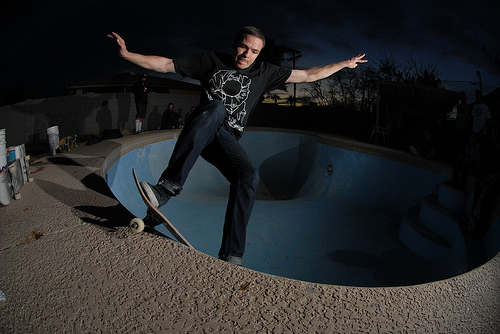How many people are pictured? 1 